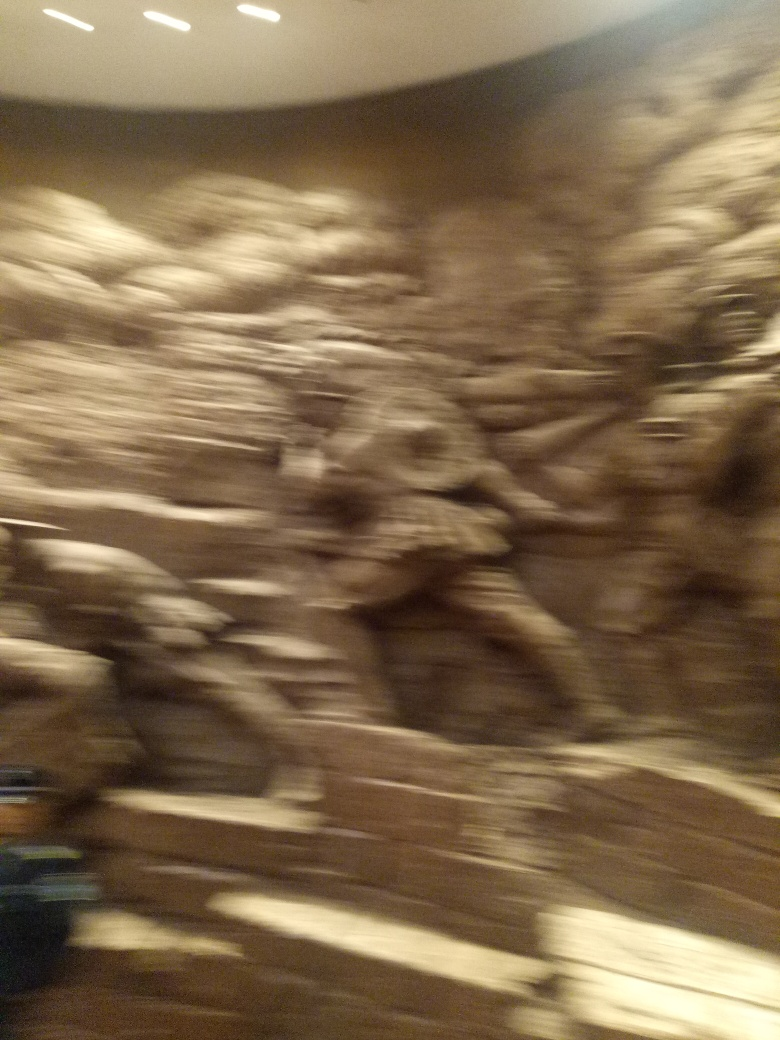If this image were part of an art collection, what title would you give it based on the visible elements? Given the abstract and somewhat chaotic nature of the photo, a fitting title might be 'Whirl of Time'. The distortion gives the image a dynamic feel, as if capturing a moment of movement or transition, which could represent the continual flow and turbulence we often experience throughout our lives. 